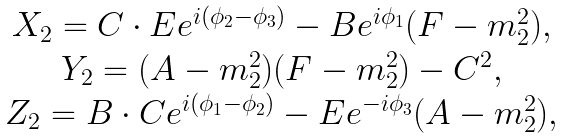<formula> <loc_0><loc_0><loc_500><loc_500>\begin{array} { c } X _ { 2 } = C \cdot E e ^ { i ( \phi _ { 2 } - \phi _ { 3 } ) } - B e ^ { i \phi _ { 1 } } ( F - m _ { 2 } ^ { 2 } ) , \\ Y _ { 2 } = ( A - m _ { 2 } ^ { 2 } ) ( F - m _ { 2 } ^ { 2 } ) - C ^ { 2 } , \\ Z _ { 2 } = B \cdot C e ^ { i ( \phi _ { 1 } - \phi _ { 2 } ) } - E e ^ { - i \phi _ { 3 } } ( A - m _ { 2 } ^ { 2 } ) , \end{array}</formula> 